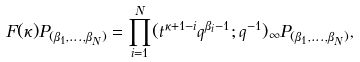<formula> <loc_0><loc_0><loc_500><loc_500>F ( \kappa ) P _ { ( \beta _ { 1 } , \dots , \beta _ { N } ) } = \prod _ { i = 1 } ^ { N } ( t ^ { \kappa + 1 - i } q ^ { \beta _ { i } - 1 } ; q ^ { - 1 } ) _ { \infty } P _ { ( \beta _ { 1 } , \dots , \beta _ { N } ) } ,</formula> 